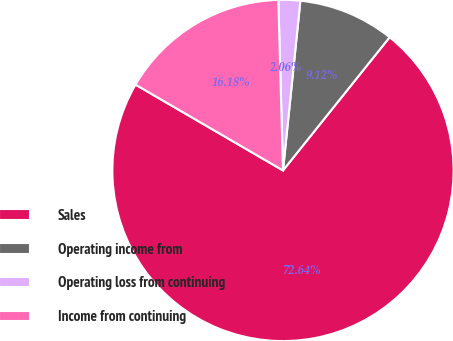Convert chart to OTSL. <chart><loc_0><loc_0><loc_500><loc_500><pie_chart><fcel>Sales<fcel>Operating income from<fcel>Operating loss from continuing<fcel>Income from continuing<nl><fcel>72.65%<fcel>9.12%<fcel>2.06%<fcel>16.18%<nl></chart> 